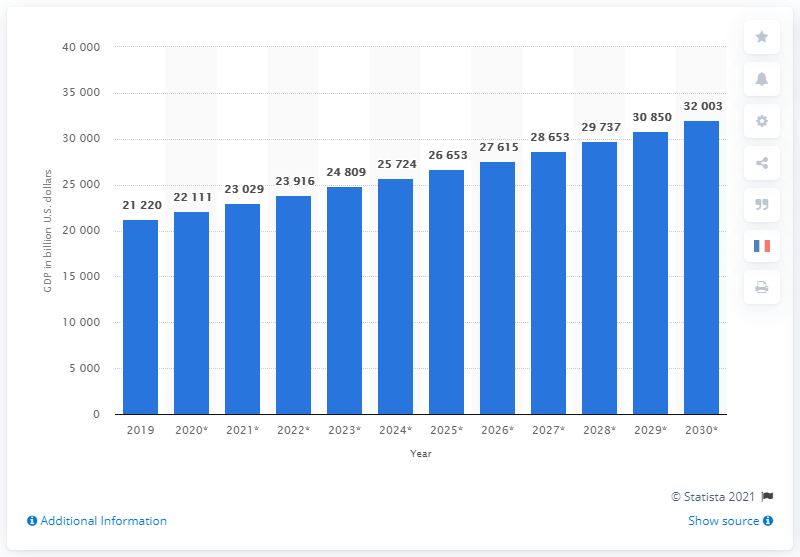Mention a couple of crucial points in this snapshot. In 2030, the projected GDP of the United States of America is expected to be 32003. In 2019, the Gross Domestic Product (GDP) of the United States was approximately 21.22 trillion dollars. 